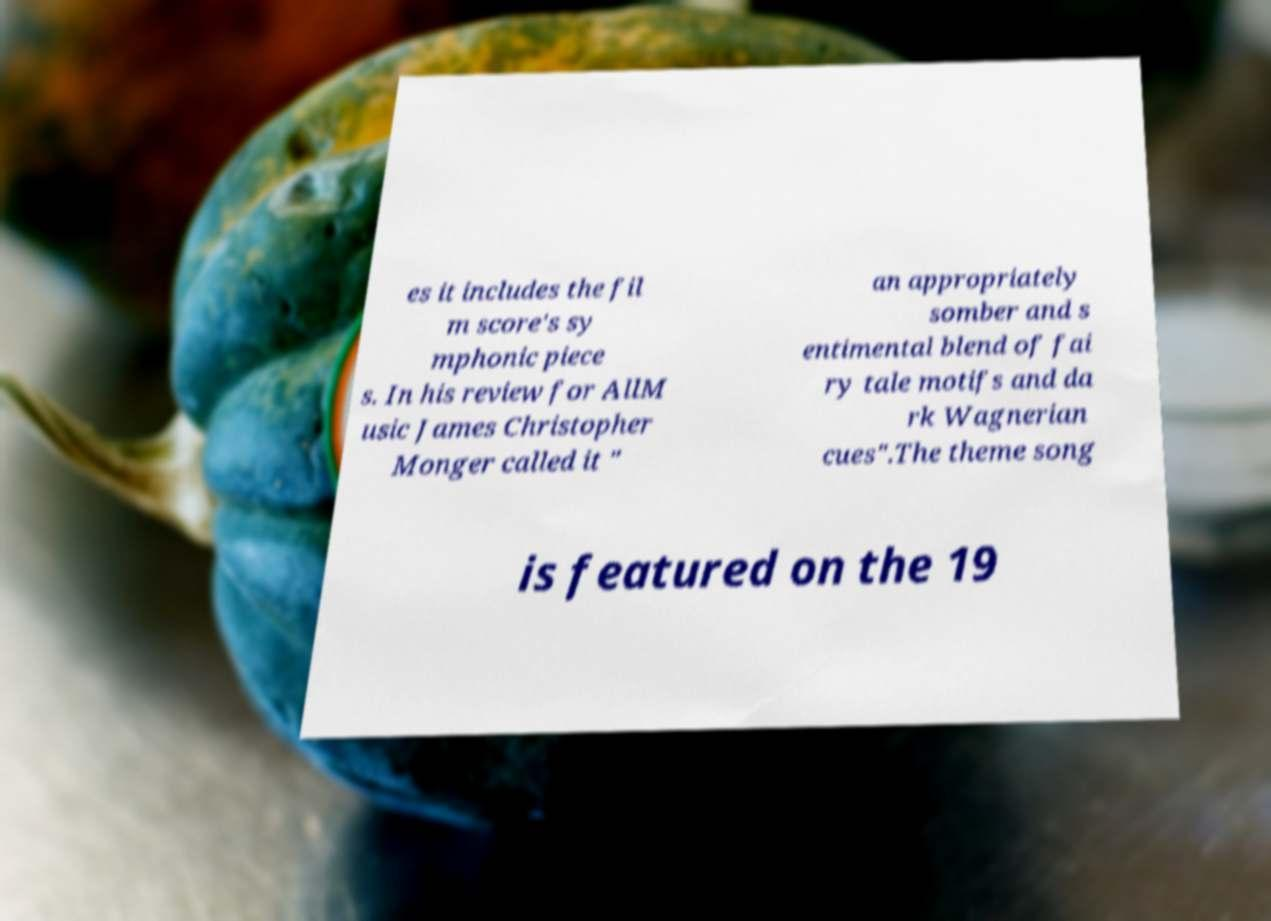Could you assist in decoding the text presented in this image and type it out clearly? es it includes the fil m score's sy mphonic piece s. In his review for AllM usic James Christopher Monger called it " an appropriately somber and s entimental blend of fai ry tale motifs and da rk Wagnerian cues".The theme song is featured on the 19 